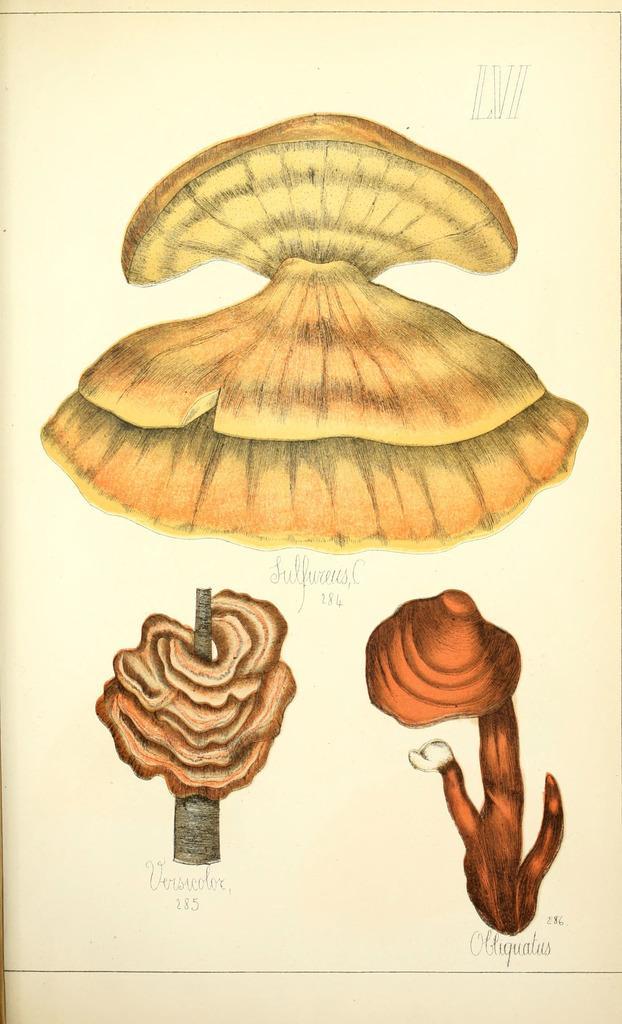Could you give a brief overview of what you see in this image? Here in this image we can see some pictures printed on a paper. 